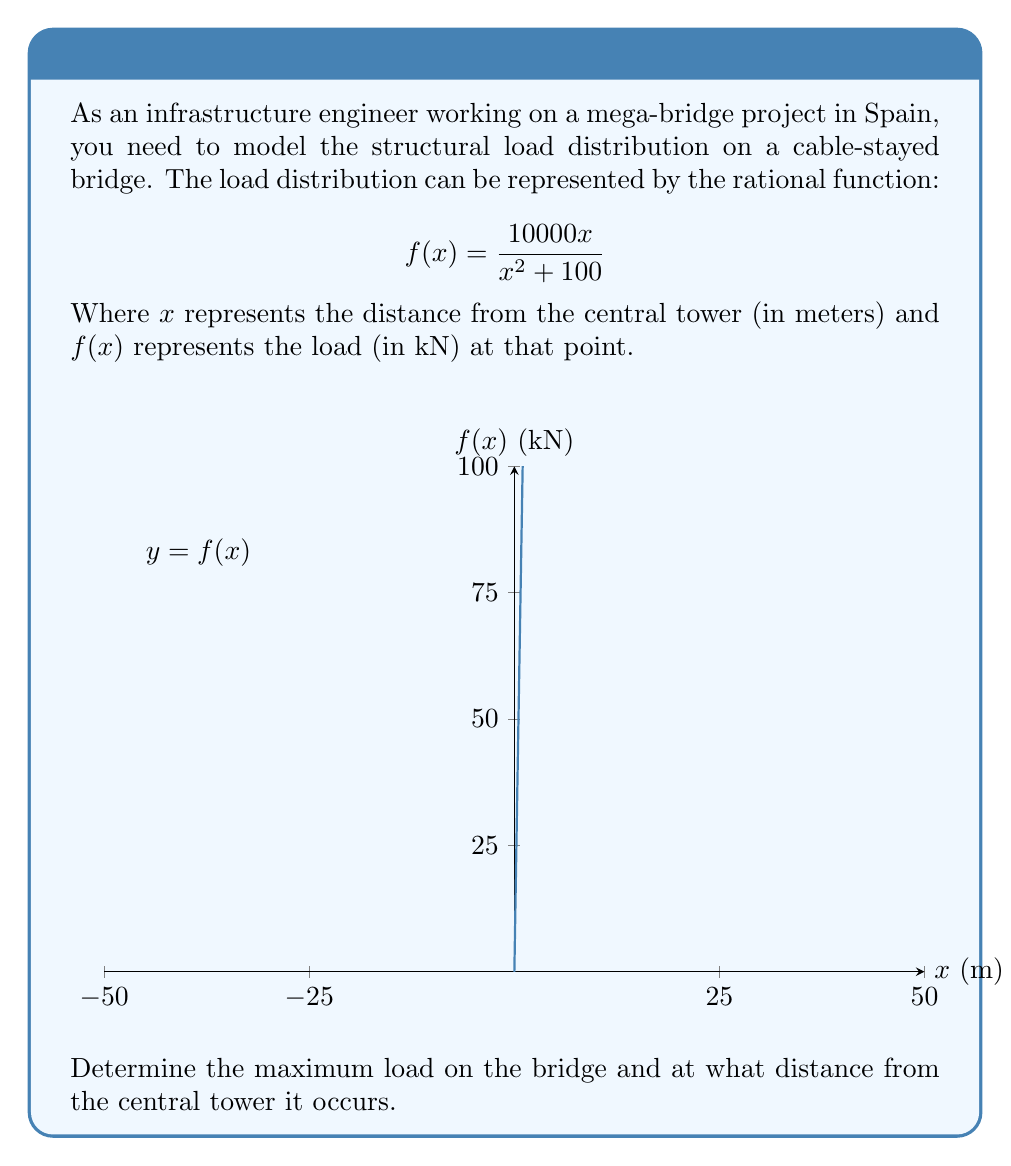What is the answer to this math problem? To find the maximum load and its location, we need to follow these steps:

1) Find the derivative of $f(x)$:
   $$f'(x) = \frac{10000(x^2+100) - 10000x(2x)}{(x^2+100)^2}$$
   $$f'(x) = \frac{1000000 - 10000x^2}{(x^2+100)^2}$$

2) Set $f'(x) = 0$ to find critical points:
   $$\frac{1000000 - 10000x^2}{(x^2+100)^2} = 0$$
   $$1000000 - 10000x^2 = 0$$
   $$x^2 = 100$$
   $$x = \pm 10$$

3) Since we're dealing with distance, we'll consider the positive value: $x = 10$ meters.

4) Calculate the maximum load by plugging $x = 10$ into the original function:
   $$f(10) = \frac{10000(10)}{10^2 + 100} = \frac{100000}{200} = 500$$

Therefore, the maximum load is 500 kN and occurs 10 meters from the central tower.
Answer: Maximum load: 500 kN at 10 meters from the central tower 